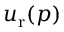Convert formula to latex. <formula><loc_0><loc_0><loc_500><loc_500>u _ { r } ( p )</formula> 